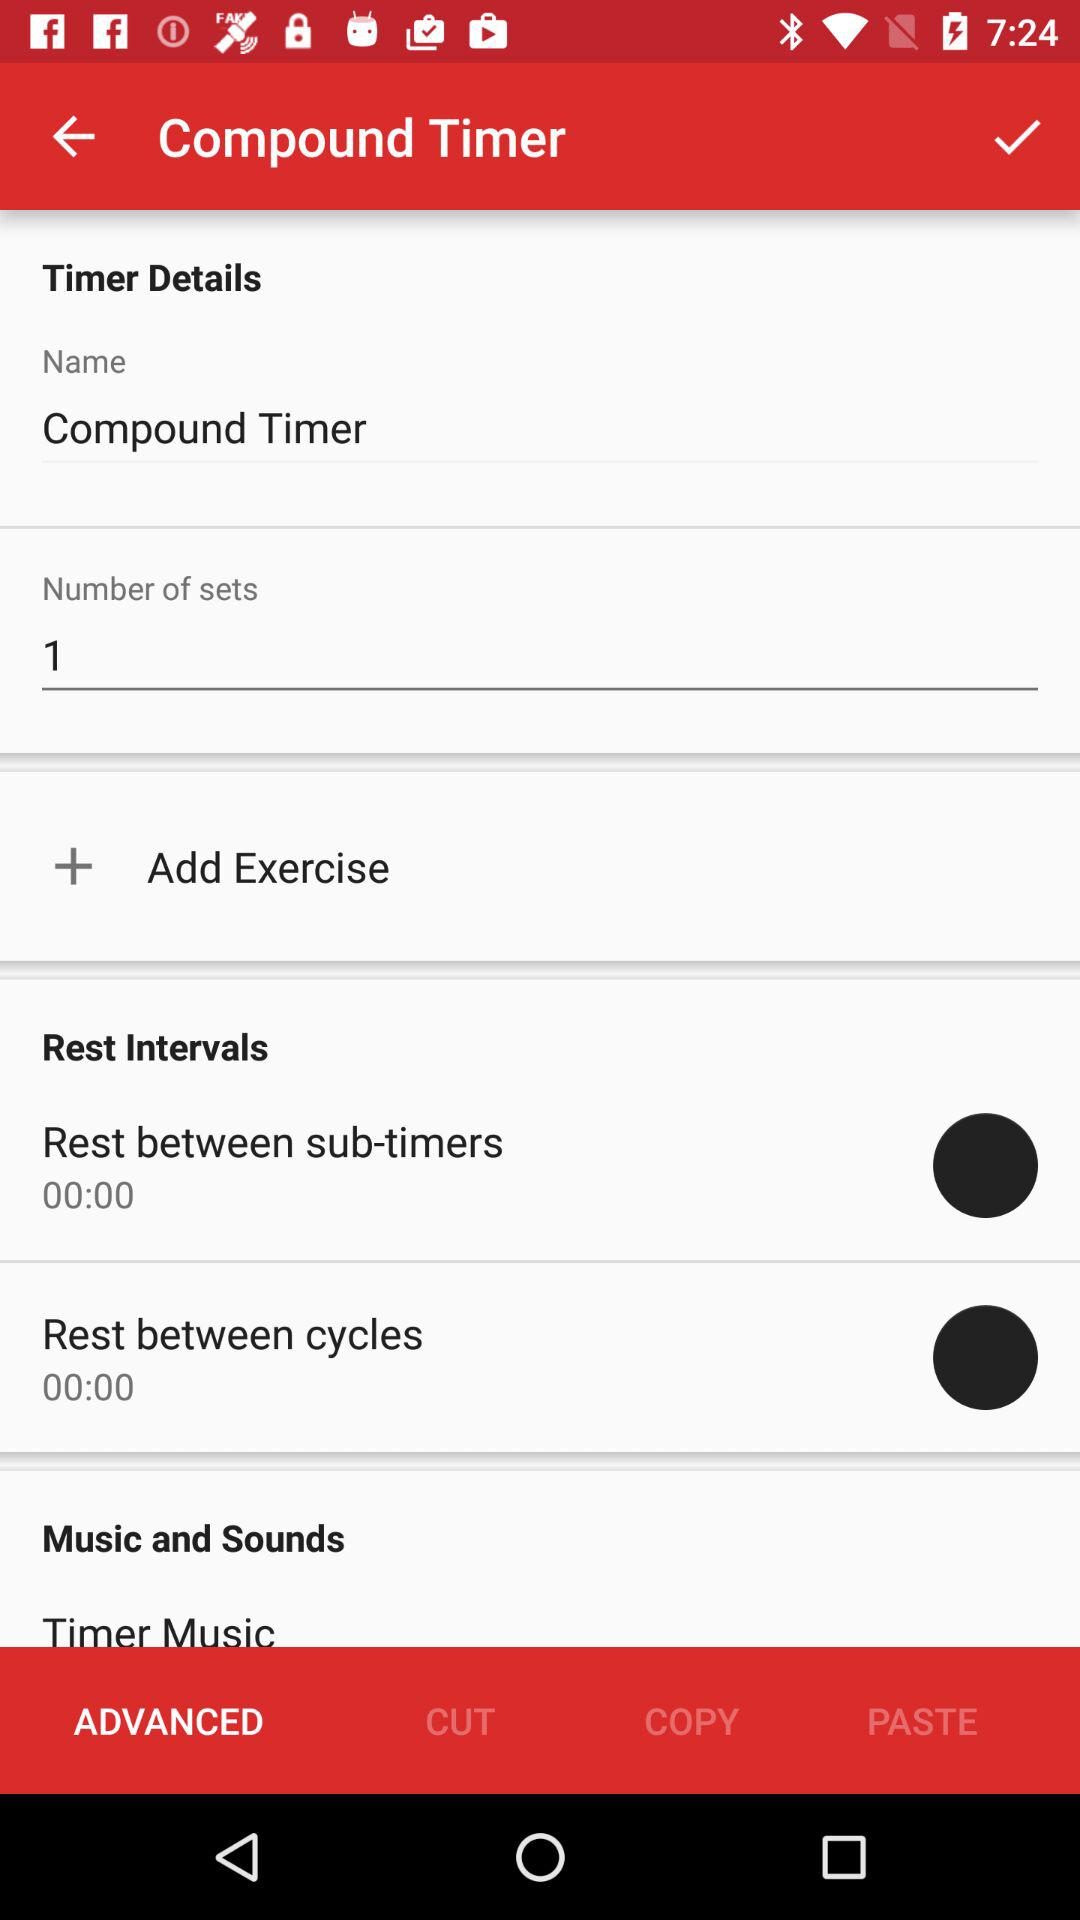How many sets are there in this timer?
Answer the question using a single word or phrase. 1 